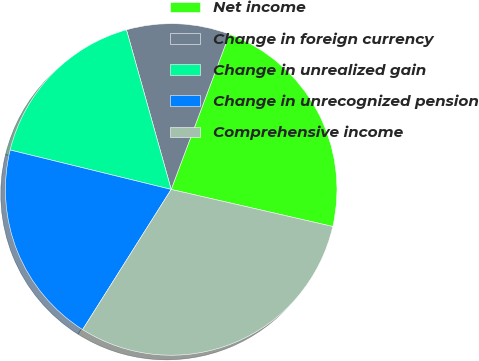<chart> <loc_0><loc_0><loc_500><loc_500><pie_chart><fcel>Net income<fcel>Change in foreign currency<fcel>Change in unrealized gain<fcel>Change in unrecognized pension<fcel>Comprehensive income<nl><fcel>22.88%<fcel>10.06%<fcel>16.83%<fcel>19.85%<fcel>30.38%<nl></chart> 